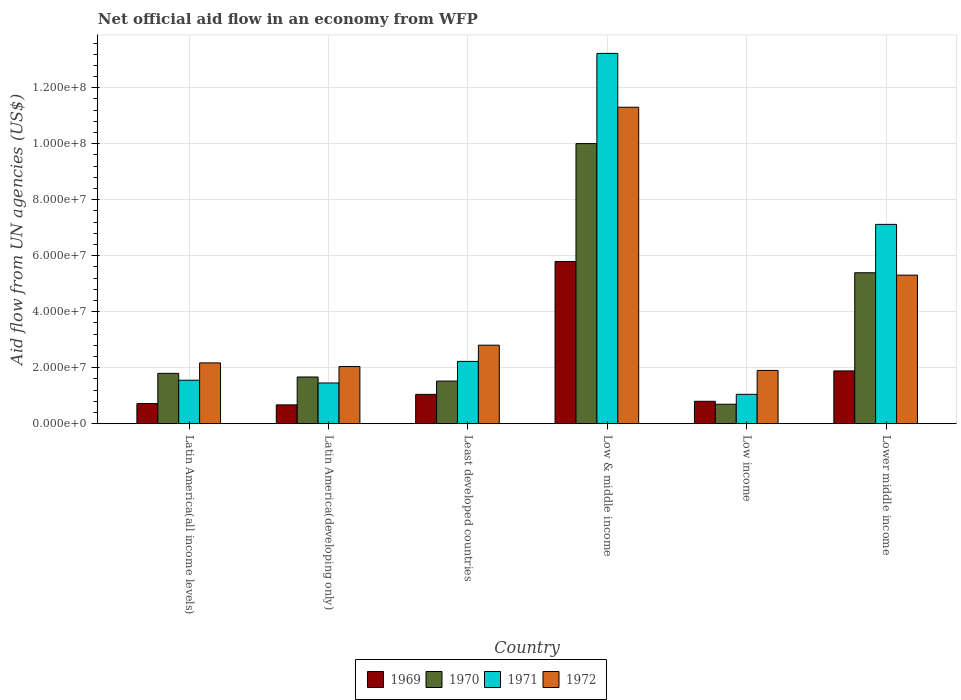How many groups of bars are there?
Offer a very short reply. 6. Are the number of bars on each tick of the X-axis equal?
Give a very brief answer. Yes. How many bars are there on the 6th tick from the left?
Ensure brevity in your answer.  4. What is the label of the 3rd group of bars from the left?
Offer a terse response. Least developed countries. What is the net official aid flow in 1972 in Lower middle income?
Provide a succinct answer. 5.31e+07. Across all countries, what is the maximum net official aid flow in 1969?
Provide a succinct answer. 5.80e+07. Across all countries, what is the minimum net official aid flow in 1970?
Give a very brief answer. 6.97e+06. In which country was the net official aid flow in 1972 minimum?
Your answer should be compact. Low income. What is the total net official aid flow in 1969 in the graph?
Offer a terse response. 1.09e+08. What is the difference between the net official aid flow in 1971 in Latin America(all income levels) and that in Lower middle income?
Provide a succinct answer. -5.57e+07. What is the difference between the net official aid flow in 1972 in Low income and the net official aid flow in 1971 in Latin America(developing only)?
Make the answer very short. 4.48e+06. What is the average net official aid flow in 1971 per country?
Provide a short and direct response. 4.44e+07. What is the difference between the net official aid flow of/in 1969 and net official aid flow of/in 1972 in Low income?
Your response must be concise. -1.10e+07. What is the ratio of the net official aid flow in 1970 in Low income to that in Lower middle income?
Offer a very short reply. 0.13. What is the difference between the highest and the second highest net official aid flow in 1969?
Offer a terse response. 3.91e+07. What is the difference between the highest and the lowest net official aid flow in 1972?
Give a very brief answer. 9.40e+07. In how many countries, is the net official aid flow in 1972 greater than the average net official aid flow in 1972 taken over all countries?
Provide a succinct answer. 2. What does the 3rd bar from the right in Latin America(developing only) represents?
Your answer should be compact. 1970. How many bars are there?
Your response must be concise. 24. Are all the bars in the graph horizontal?
Your answer should be very brief. No. How many countries are there in the graph?
Offer a terse response. 6. Are the values on the major ticks of Y-axis written in scientific E-notation?
Your answer should be very brief. Yes. Does the graph contain any zero values?
Ensure brevity in your answer.  No. Where does the legend appear in the graph?
Ensure brevity in your answer.  Bottom center. How many legend labels are there?
Offer a very short reply. 4. What is the title of the graph?
Your answer should be very brief. Net official aid flow in an economy from WFP. What is the label or title of the Y-axis?
Your response must be concise. Aid flow from UN agencies (US$). What is the Aid flow from UN agencies (US$) in 1969 in Latin America(all income levels)?
Give a very brief answer. 7.21e+06. What is the Aid flow from UN agencies (US$) of 1970 in Latin America(all income levels)?
Offer a terse response. 1.80e+07. What is the Aid flow from UN agencies (US$) of 1971 in Latin America(all income levels)?
Provide a short and direct response. 1.56e+07. What is the Aid flow from UN agencies (US$) in 1972 in Latin America(all income levels)?
Make the answer very short. 2.17e+07. What is the Aid flow from UN agencies (US$) of 1969 in Latin America(developing only)?
Provide a short and direct response. 6.74e+06. What is the Aid flow from UN agencies (US$) of 1970 in Latin America(developing only)?
Offer a very short reply. 1.67e+07. What is the Aid flow from UN agencies (US$) in 1971 in Latin America(developing only)?
Give a very brief answer. 1.46e+07. What is the Aid flow from UN agencies (US$) of 1972 in Latin America(developing only)?
Your answer should be very brief. 2.04e+07. What is the Aid flow from UN agencies (US$) of 1969 in Least developed countries?
Keep it short and to the point. 1.05e+07. What is the Aid flow from UN agencies (US$) in 1970 in Least developed countries?
Provide a succinct answer. 1.52e+07. What is the Aid flow from UN agencies (US$) of 1971 in Least developed countries?
Provide a short and direct response. 2.23e+07. What is the Aid flow from UN agencies (US$) in 1972 in Least developed countries?
Your answer should be very brief. 2.81e+07. What is the Aid flow from UN agencies (US$) of 1969 in Low & middle income?
Provide a short and direct response. 5.80e+07. What is the Aid flow from UN agencies (US$) in 1970 in Low & middle income?
Give a very brief answer. 1.00e+08. What is the Aid flow from UN agencies (US$) in 1971 in Low & middle income?
Your answer should be compact. 1.32e+08. What is the Aid flow from UN agencies (US$) of 1972 in Low & middle income?
Your response must be concise. 1.13e+08. What is the Aid flow from UN agencies (US$) in 1969 in Low income?
Offer a very short reply. 8.02e+06. What is the Aid flow from UN agencies (US$) in 1970 in Low income?
Your response must be concise. 6.97e+06. What is the Aid flow from UN agencies (US$) of 1971 in Low income?
Provide a short and direct response. 1.05e+07. What is the Aid flow from UN agencies (US$) of 1972 in Low income?
Your answer should be compact. 1.90e+07. What is the Aid flow from UN agencies (US$) in 1969 in Lower middle income?
Provide a short and direct response. 1.89e+07. What is the Aid flow from UN agencies (US$) of 1970 in Lower middle income?
Give a very brief answer. 5.39e+07. What is the Aid flow from UN agencies (US$) of 1971 in Lower middle income?
Make the answer very short. 7.12e+07. What is the Aid flow from UN agencies (US$) in 1972 in Lower middle income?
Offer a very short reply. 5.31e+07. Across all countries, what is the maximum Aid flow from UN agencies (US$) of 1969?
Offer a terse response. 5.80e+07. Across all countries, what is the maximum Aid flow from UN agencies (US$) of 1970?
Provide a short and direct response. 1.00e+08. Across all countries, what is the maximum Aid flow from UN agencies (US$) in 1971?
Your answer should be compact. 1.32e+08. Across all countries, what is the maximum Aid flow from UN agencies (US$) in 1972?
Your response must be concise. 1.13e+08. Across all countries, what is the minimum Aid flow from UN agencies (US$) of 1969?
Your answer should be very brief. 6.74e+06. Across all countries, what is the minimum Aid flow from UN agencies (US$) in 1970?
Offer a very short reply. 6.97e+06. Across all countries, what is the minimum Aid flow from UN agencies (US$) in 1971?
Offer a very short reply. 1.05e+07. Across all countries, what is the minimum Aid flow from UN agencies (US$) of 1972?
Ensure brevity in your answer.  1.90e+07. What is the total Aid flow from UN agencies (US$) in 1969 in the graph?
Make the answer very short. 1.09e+08. What is the total Aid flow from UN agencies (US$) of 1970 in the graph?
Ensure brevity in your answer.  2.11e+08. What is the total Aid flow from UN agencies (US$) in 1971 in the graph?
Your answer should be compact. 2.66e+08. What is the total Aid flow from UN agencies (US$) of 1972 in the graph?
Your answer should be very brief. 2.55e+08. What is the difference between the Aid flow from UN agencies (US$) in 1970 in Latin America(all income levels) and that in Latin America(developing only)?
Your response must be concise. 1.30e+06. What is the difference between the Aid flow from UN agencies (US$) in 1971 in Latin America(all income levels) and that in Latin America(developing only)?
Give a very brief answer. 9.90e+05. What is the difference between the Aid flow from UN agencies (US$) of 1972 in Latin America(all income levels) and that in Latin America(developing only)?
Provide a short and direct response. 1.30e+06. What is the difference between the Aid flow from UN agencies (US$) in 1969 in Latin America(all income levels) and that in Least developed countries?
Offer a terse response. -3.28e+06. What is the difference between the Aid flow from UN agencies (US$) in 1970 in Latin America(all income levels) and that in Least developed countries?
Offer a very short reply. 2.76e+06. What is the difference between the Aid flow from UN agencies (US$) in 1971 in Latin America(all income levels) and that in Least developed countries?
Your answer should be compact. -6.72e+06. What is the difference between the Aid flow from UN agencies (US$) in 1972 in Latin America(all income levels) and that in Least developed countries?
Ensure brevity in your answer.  -6.33e+06. What is the difference between the Aid flow from UN agencies (US$) of 1969 in Latin America(all income levels) and that in Low & middle income?
Your response must be concise. -5.08e+07. What is the difference between the Aid flow from UN agencies (US$) in 1970 in Latin America(all income levels) and that in Low & middle income?
Offer a terse response. -8.21e+07. What is the difference between the Aid flow from UN agencies (US$) in 1971 in Latin America(all income levels) and that in Low & middle income?
Your response must be concise. -1.17e+08. What is the difference between the Aid flow from UN agencies (US$) of 1972 in Latin America(all income levels) and that in Low & middle income?
Offer a very short reply. -9.13e+07. What is the difference between the Aid flow from UN agencies (US$) in 1969 in Latin America(all income levels) and that in Low income?
Give a very brief answer. -8.10e+05. What is the difference between the Aid flow from UN agencies (US$) of 1970 in Latin America(all income levels) and that in Low income?
Your response must be concise. 1.10e+07. What is the difference between the Aid flow from UN agencies (US$) of 1971 in Latin America(all income levels) and that in Low income?
Your response must be concise. 5.04e+06. What is the difference between the Aid flow from UN agencies (US$) in 1972 in Latin America(all income levels) and that in Low income?
Provide a short and direct response. 2.69e+06. What is the difference between the Aid flow from UN agencies (US$) of 1969 in Latin America(all income levels) and that in Lower middle income?
Keep it short and to the point. -1.17e+07. What is the difference between the Aid flow from UN agencies (US$) of 1970 in Latin America(all income levels) and that in Lower middle income?
Give a very brief answer. -3.59e+07. What is the difference between the Aid flow from UN agencies (US$) of 1971 in Latin America(all income levels) and that in Lower middle income?
Your answer should be very brief. -5.57e+07. What is the difference between the Aid flow from UN agencies (US$) in 1972 in Latin America(all income levels) and that in Lower middle income?
Give a very brief answer. -3.14e+07. What is the difference between the Aid flow from UN agencies (US$) in 1969 in Latin America(developing only) and that in Least developed countries?
Your answer should be very brief. -3.75e+06. What is the difference between the Aid flow from UN agencies (US$) in 1970 in Latin America(developing only) and that in Least developed countries?
Your answer should be very brief. 1.46e+06. What is the difference between the Aid flow from UN agencies (US$) in 1971 in Latin America(developing only) and that in Least developed countries?
Provide a short and direct response. -7.71e+06. What is the difference between the Aid flow from UN agencies (US$) in 1972 in Latin America(developing only) and that in Least developed countries?
Your response must be concise. -7.63e+06. What is the difference between the Aid flow from UN agencies (US$) of 1969 in Latin America(developing only) and that in Low & middle income?
Offer a terse response. -5.12e+07. What is the difference between the Aid flow from UN agencies (US$) in 1970 in Latin America(developing only) and that in Low & middle income?
Give a very brief answer. -8.34e+07. What is the difference between the Aid flow from UN agencies (US$) in 1971 in Latin America(developing only) and that in Low & middle income?
Ensure brevity in your answer.  -1.18e+08. What is the difference between the Aid flow from UN agencies (US$) in 1972 in Latin America(developing only) and that in Low & middle income?
Ensure brevity in your answer.  -9.26e+07. What is the difference between the Aid flow from UN agencies (US$) in 1969 in Latin America(developing only) and that in Low income?
Ensure brevity in your answer.  -1.28e+06. What is the difference between the Aid flow from UN agencies (US$) of 1970 in Latin America(developing only) and that in Low income?
Offer a terse response. 9.73e+06. What is the difference between the Aid flow from UN agencies (US$) of 1971 in Latin America(developing only) and that in Low income?
Keep it short and to the point. 4.05e+06. What is the difference between the Aid flow from UN agencies (US$) of 1972 in Latin America(developing only) and that in Low income?
Your response must be concise. 1.39e+06. What is the difference between the Aid flow from UN agencies (US$) of 1969 in Latin America(developing only) and that in Lower middle income?
Make the answer very short. -1.21e+07. What is the difference between the Aid flow from UN agencies (US$) in 1970 in Latin America(developing only) and that in Lower middle income?
Keep it short and to the point. -3.72e+07. What is the difference between the Aid flow from UN agencies (US$) in 1971 in Latin America(developing only) and that in Lower middle income?
Make the answer very short. -5.66e+07. What is the difference between the Aid flow from UN agencies (US$) in 1972 in Latin America(developing only) and that in Lower middle income?
Offer a very short reply. -3.26e+07. What is the difference between the Aid flow from UN agencies (US$) of 1969 in Least developed countries and that in Low & middle income?
Give a very brief answer. -4.75e+07. What is the difference between the Aid flow from UN agencies (US$) of 1970 in Least developed countries and that in Low & middle income?
Make the answer very short. -8.48e+07. What is the difference between the Aid flow from UN agencies (US$) of 1971 in Least developed countries and that in Low & middle income?
Your answer should be compact. -1.10e+08. What is the difference between the Aid flow from UN agencies (US$) in 1972 in Least developed countries and that in Low & middle income?
Your answer should be compact. -8.50e+07. What is the difference between the Aid flow from UN agencies (US$) of 1969 in Least developed countries and that in Low income?
Offer a terse response. 2.47e+06. What is the difference between the Aid flow from UN agencies (US$) in 1970 in Least developed countries and that in Low income?
Give a very brief answer. 8.27e+06. What is the difference between the Aid flow from UN agencies (US$) of 1971 in Least developed countries and that in Low income?
Make the answer very short. 1.18e+07. What is the difference between the Aid flow from UN agencies (US$) of 1972 in Least developed countries and that in Low income?
Your answer should be compact. 9.02e+06. What is the difference between the Aid flow from UN agencies (US$) of 1969 in Least developed countries and that in Lower middle income?
Offer a very short reply. -8.38e+06. What is the difference between the Aid flow from UN agencies (US$) of 1970 in Least developed countries and that in Lower middle income?
Provide a succinct answer. -3.87e+07. What is the difference between the Aid flow from UN agencies (US$) of 1971 in Least developed countries and that in Lower middle income?
Make the answer very short. -4.89e+07. What is the difference between the Aid flow from UN agencies (US$) of 1972 in Least developed countries and that in Lower middle income?
Keep it short and to the point. -2.50e+07. What is the difference between the Aid flow from UN agencies (US$) of 1969 in Low & middle income and that in Low income?
Ensure brevity in your answer.  4.99e+07. What is the difference between the Aid flow from UN agencies (US$) in 1970 in Low & middle income and that in Low income?
Provide a succinct answer. 9.31e+07. What is the difference between the Aid flow from UN agencies (US$) of 1971 in Low & middle income and that in Low income?
Your answer should be compact. 1.22e+08. What is the difference between the Aid flow from UN agencies (US$) in 1972 in Low & middle income and that in Low income?
Your answer should be compact. 9.40e+07. What is the difference between the Aid flow from UN agencies (US$) in 1969 in Low & middle income and that in Lower middle income?
Provide a succinct answer. 3.91e+07. What is the difference between the Aid flow from UN agencies (US$) in 1970 in Low & middle income and that in Lower middle income?
Your response must be concise. 4.61e+07. What is the difference between the Aid flow from UN agencies (US$) of 1971 in Low & middle income and that in Lower middle income?
Your answer should be very brief. 6.11e+07. What is the difference between the Aid flow from UN agencies (US$) of 1972 in Low & middle income and that in Lower middle income?
Keep it short and to the point. 6.00e+07. What is the difference between the Aid flow from UN agencies (US$) in 1969 in Low income and that in Lower middle income?
Offer a terse response. -1.08e+07. What is the difference between the Aid flow from UN agencies (US$) of 1970 in Low income and that in Lower middle income?
Make the answer very short. -4.70e+07. What is the difference between the Aid flow from UN agencies (US$) in 1971 in Low income and that in Lower middle income?
Give a very brief answer. -6.07e+07. What is the difference between the Aid flow from UN agencies (US$) in 1972 in Low income and that in Lower middle income?
Your answer should be very brief. -3.40e+07. What is the difference between the Aid flow from UN agencies (US$) in 1969 in Latin America(all income levels) and the Aid flow from UN agencies (US$) in 1970 in Latin America(developing only)?
Make the answer very short. -9.49e+06. What is the difference between the Aid flow from UN agencies (US$) in 1969 in Latin America(all income levels) and the Aid flow from UN agencies (US$) in 1971 in Latin America(developing only)?
Your answer should be very brief. -7.35e+06. What is the difference between the Aid flow from UN agencies (US$) in 1969 in Latin America(all income levels) and the Aid flow from UN agencies (US$) in 1972 in Latin America(developing only)?
Offer a terse response. -1.32e+07. What is the difference between the Aid flow from UN agencies (US$) of 1970 in Latin America(all income levels) and the Aid flow from UN agencies (US$) of 1971 in Latin America(developing only)?
Keep it short and to the point. 3.44e+06. What is the difference between the Aid flow from UN agencies (US$) of 1970 in Latin America(all income levels) and the Aid flow from UN agencies (US$) of 1972 in Latin America(developing only)?
Keep it short and to the point. -2.43e+06. What is the difference between the Aid flow from UN agencies (US$) in 1971 in Latin America(all income levels) and the Aid flow from UN agencies (US$) in 1972 in Latin America(developing only)?
Make the answer very short. -4.88e+06. What is the difference between the Aid flow from UN agencies (US$) in 1969 in Latin America(all income levels) and the Aid flow from UN agencies (US$) in 1970 in Least developed countries?
Keep it short and to the point. -8.03e+06. What is the difference between the Aid flow from UN agencies (US$) in 1969 in Latin America(all income levels) and the Aid flow from UN agencies (US$) in 1971 in Least developed countries?
Ensure brevity in your answer.  -1.51e+07. What is the difference between the Aid flow from UN agencies (US$) of 1969 in Latin America(all income levels) and the Aid flow from UN agencies (US$) of 1972 in Least developed countries?
Ensure brevity in your answer.  -2.08e+07. What is the difference between the Aid flow from UN agencies (US$) in 1970 in Latin America(all income levels) and the Aid flow from UN agencies (US$) in 1971 in Least developed countries?
Ensure brevity in your answer.  -4.27e+06. What is the difference between the Aid flow from UN agencies (US$) of 1970 in Latin America(all income levels) and the Aid flow from UN agencies (US$) of 1972 in Least developed countries?
Your response must be concise. -1.01e+07. What is the difference between the Aid flow from UN agencies (US$) of 1971 in Latin America(all income levels) and the Aid flow from UN agencies (US$) of 1972 in Least developed countries?
Provide a short and direct response. -1.25e+07. What is the difference between the Aid flow from UN agencies (US$) in 1969 in Latin America(all income levels) and the Aid flow from UN agencies (US$) in 1970 in Low & middle income?
Offer a terse response. -9.29e+07. What is the difference between the Aid flow from UN agencies (US$) of 1969 in Latin America(all income levels) and the Aid flow from UN agencies (US$) of 1971 in Low & middle income?
Your answer should be compact. -1.25e+08. What is the difference between the Aid flow from UN agencies (US$) in 1969 in Latin America(all income levels) and the Aid flow from UN agencies (US$) in 1972 in Low & middle income?
Keep it short and to the point. -1.06e+08. What is the difference between the Aid flow from UN agencies (US$) in 1970 in Latin America(all income levels) and the Aid flow from UN agencies (US$) in 1971 in Low & middle income?
Your response must be concise. -1.14e+08. What is the difference between the Aid flow from UN agencies (US$) of 1970 in Latin America(all income levels) and the Aid flow from UN agencies (US$) of 1972 in Low & middle income?
Offer a very short reply. -9.51e+07. What is the difference between the Aid flow from UN agencies (US$) of 1971 in Latin America(all income levels) and the Aid flow from UN agencies (US$) of 1972 in Low & middle income?
Your answer should be very brief. -9.75e+07. What is the difference between the Aid flow from UN agencies (US$) in 1969 in Latin America(all income levels) and the Aid flow from UN agencies (US$) in 1971 in Low income?
Ensure brevity in your answer.  -3.30e+06. What is the difference between the Aid flow from UN agencies (US$) in 1969 in Latin America(all income levels) and the Aid flow from UN agencies (US$) in 1972 in Low income?
Make the answer very short. -1.18e+07. What is the difference between the Aid flow from UN agencies (US$) of 1970 in Latin America(all income levels) and the Aid flow from UN agencies (US$) of 1971 in Low income?
Your answer should be very brief. 7.49e+06. What is the difference between the Aid flow from UN agencies (US$) of 1970 in Latin America(all income levels) and the Aid flow from UN agencies (US$) of 1972 in Low income?
Provide a short and direct response. -1.04e+06. What is the difference between the Aid flow from UN agencies (US$) of 1971 in Latin America(all income levels) and the Aid flow from UN agencies (US$) of 1972 in Low income?
Ensure brevity in your answer.  -3.49e+06. What is the difference between the Aid flow from UN agencies (US$) in 1969 in Latin America(all income levels) and the Aid flow from UN agencies (US$) in 1970 in Lower middle income?
Make the answer very short. -4.67e+07. What is the difference between the Aid flow from UN agencies (US$) in 1969 in Latin America(all income levels) and the Aid flow from UN agencies (US$) in 1971 in Lower middle income?
Your response must be concise. -6.40e+07. What is the difference between the Aid flow from UN agencies (US$) in 1969 in Latin America(all income levels) and the Aid flow from UN agencies (US$) in 1972 in Lower middle income?
Make the answer very short. -4.59e+07. What is the difference between the Aid flow from UN agencies (US$) in 1970 in Latin America(all income levels) and the Aid flow from UN agencies (US$) in 1971 in Lower middle income?
Your answer should be compact. -5.32e+07. What is the difference between the Aid flow from UN agencies (US$) of 1970 in Latin America(all income levels) and the Aid flow from UN agencies (US$) of 1972 in Lower middle income?
Provide a short and direct response. -3.51e+07. What is the difference between the Aid flow from UN agencies (US$) in 1971 in Latin America(all income levels) and the Aid flow from UN agencies (US$) in 1972 in Lower middle income?
Your response must be concise. -3.75e+07. What is the difference between the Aid flow from UN agencies (US$) of 1969 in Latin America(developing only) and the Aid flow from UN agencies (US$) of 1970 in Least developed countries?
Give a very brief answer. -8.50e+06. What is the difference between the Aid flow from UN agencies (US$) in 1969 in Latin America(developing only) and the Aid flow from UN agencies (US$) in 1971 in Least developed countries?
Provide a succinct answer. -1.55e+07. What is the difference between the Aid flow from UN agencies (US$) in 1969 in Latin America(developing only) and the Aid flow from UN agencies (US$) in 1972 in Least developed countries?
Offer a very short reply. -2.13e+07. What is the difference between the Aid flow from UN agencies (US$) in 1970 in Latin America(developing only) and the Aid flow from UN agencies (US$) in 1971 in Least developed countries?
Your response must be concise. -5.57e+06. What is the difference between the Aid flow from UN agencies (US$) of 1970 in Latin America(developing only) and the Aid flow from UN agencies (US$) of 1972 in Least developed countries?
Keep it short and to the point. -1.14e+07. What is the difference between the Aid flow from UN agencies (US$) of 1971 in Latin America(developing only) and the Aid flow from UN agencies (US$) of 1972 in Least developed countries?
Give a very brief answer. -1.35e+07. What is the difference between the Aid flow from UN agencies (US$) of 1969 in Latin America(developing only) and the Aid flow from UN agencies (US$) of 1970 in Low & middle income?
Make the answer very short. -9.33e+07. What is the difference between the Aid flow from UN agencies (US$) in 1969 in Latin America(developing only) and the Aid flow from UN agencies (US$) in 1971 in Low & middle income?
Provide a short and direct response. -1.26e+08. What is the difference between the Aid flow from UN agencies (US$) of 1969 in Latin America(developing only) and the Aid flow from UN agencies (US$) of 1972 in Low & middle income?
Your response must be concise. -1.06e+08. What is the difference between the Aid flow from UN agencies (US$) of 1970 in Latin America(developing only) and the Aid flow from UN agencies (US$) of 1971 in Low & middle income?
Provide a succinct answer. -1.16e+08. What is the difference between the Aid flow from UN agencies (US$) of 1970 in Latin America(developing only) and the Aid flow from UN agencies (US$) of 1972 in Low & middle income?
Provide a short and direct response. -9.64e+07. What is the difference between the Aid flow from UN agencies (US$) in 1971 in Latin America(developing only) and the Aid flow from UN agencies (US$) in 1972 in Low & middle income?
Ensure brevity in your answer.  -9.85e+07. What is the difference between the Aid flow from UN agencies (US$) in 1969 in Latin America(developing only) and the Aid flow from UN agencies (US$) in 1970 in Low income?
Provide a succinct answer. -2.30e+05. What is the difference between the Aid flow from UN agencies (US$) in 1969 in Latin America(developing only) and the Aid flow from UN agencies (US$) in 1971 in Low income?
Ensure brevity in your answer.  -3.77e+06. What is the difference between the Aid flow from UN agencies (US$) in 1969 in Latin America(developing only) and the Aid flow from UN agencies (US$) in 1972 in Low income?
Keep it short and to the point. -1.23e+07. What is the difference between the Aid flow from UN agencies (US$) of 1970 in Latin America(developing only) and the Aid flow from UN agencies (US$) of 1971 in Low income?
Provide a succinct answer. 6.19e+06. What is the difference between the Aid flow from UN agencies (US$) in 1970 in Latin America(developing only) and the Aid flow from UN agencies (US$) in 1972 in Low income?
Your answer should be very brief. -2.34e+06. What is the difference between the Aid flow from UN agencies (US$) of 1971 in Latin America(developing only) and the Aid flow from UN agencies (US$) of 1972 in Low income?
Offer a very short reply. -4.48e+06. What is the difference between the Aid flow from UN agencies (US$) of 1969 in Latin America(developing only) and the Aid flow from UN agencies (US$) of 1970 in Lower middle income?
Provide a succinct answer. -4.72e+07. What is the difference between the Aid flow from UN agencies (US$) of 1969 in Latin America(developing only) and the Aid flow from UN agencies (US$) of 1971 in Lower middle income?
Provide a succinct answer. -6.45e+07. What is the difference between the Aid flow from UN agencies (US$) in 1969 in Latin America(developing only) and the Aid flow from UN agencies (US$) in 1972 in Lower middle income?
Provide a short and direct response. -4.63e+07. What is the difference between the Aid flow from UN agencies (US$) of 1970 in Latin America(developing only) and the Aid flow from UN agencies (US$) of 1971 in Lower middle income?
Make the answer very short. -5.45e+07. What is the difference between the Aid flow from UN agencies (US$) of 1970 in Latin America(developing only) and the Aid flow from UN agencies (US$) of 1972 in Lower middle income?
Keep it short and to the point. -3.64e+07. What is the difference between the Aid flow from UN agencies (US$) in 1971 in Latin America(developing only) and the Aid flow from UN agencies (US$) in 1972 in Lower middle income?
Ensure brevity in your answer.  -3.85e+07. What is the difference between the Aid flow from UN agencies (US$) in 1969 in Least developed countries and the Aid flow from UN agencies (US$) in 1970 in Low & middle income?
Provide a succinct answer. -8.96e+07. What is the difference between the Aid flow from UN agencies (US$) in 1969 in Least developed countries and the Aid flow from UN agencies (US$) in 1971 in Low & middle income?
Offer a very short reply. -1.22e+08. What is the difference between the Aid flow from UN agencies (US$) of 1969 in Least developed countries and the Aid flow from UN agencies (US$) of 1972 in Low & middle income?
Your answer should be very brief. -1.03e+08. What is the difference between the Aid flow from UN agencies (US$) in 1970 in Least developed countries and the Aid flow from UN agencies (US$) in 1971 in Low & middle income?
Ensure brevity in your answer.  -1.17e+08. What is the difference between the Aid flow from UN agencies (US$) of 1970 in Least developed countries and the Aid flow from UN agencies (US$) of 1972 in Low & middle income?
Offer a very short reply. -9.78e+07. What is the difference between the Aid flow from UN agencies (US$) in 1971 in Least developed countries and the Aid flow from UN agencies (US$) in 1972 in Low & middle income?
Your answer should be compact. -9.08e+07. What is the difference between the Aid flow from UN agencies (US$) of 1969 in Least developed countries and the Aid flow from UN agencies (US$) of 1970 in Low income?
Make the answer very short. 3.52e+06. What is the difference between the Aid flow from UN agencies (US$) in 1969 in Least developed countries and the Aid flow from UN agencies (US$) in 1972 in Low income?
Provide a succinct answer. -8.55e+06. What is the difference between the Aid flow from UN agencies (US$) in 1970 in Least developed countries and the Aid flow from UN agencies (US$) in 1971 in Low income?
Your response must be concise. 4.73e+06. What is the difference between the Aid flow from UN agencies (US$) in 1970 in Least developed countries and the Aid flow from UN agencies (US$) in 1972 in Low income?
Offer a terse response. -3.80e+06. What is the difference between the Aid flow from UN agencies (US$) of 1971 in Least developed countries and the Aid flow from UN agencies (US$) of 1972 in Low income?
Keep it short and to the point. 3.23e+06. What is the difference between the Aid flow from UN agencies (US$) in 1969 in Least developed countries and the Aid flow from UN agencies (US$) in 1970 in Lower middle income?
Your answer should be compact. -4.34e+07. What is the difference between the Aid flow from UN agencies (US$) of 1969 in Least developed countries and the Aid flow from UN agencies (US$) of 1971 in Lower middle income?
Your response must be concise. -6.07e+07. What is the difference between the Aid flow from UN agencies (US$) in 1969 in Least developed countries and the Aid flow from UN agencies (US$) in 1972 in Lower middle income?
Ensure brevity in your answer.  -4.26e+07. What is the difference between the Aid flow from UN agencies (US$) of 1970 in Least developed countries and the Aid flow from UN agencies (US$) of 1971 in Lower middle income?
Ensure brevity in your answer.  -5.60e+07. What is the difference between the Aid flow from UN agencies (US$) of 1970 in Least developed countries and the Aid flow from UN agencies (US$) of 1972 in Lower middle income?
Give a very brief answer. -3.78e+07. What is the difference between the Aid flow from UN agencies (US$) in 1971 in Least developed countries and the Aid flow from UN agencies (US$) in 1972 in Lower middle income?
Your answer should be compact. -3.08e+07. What is the difference between the Aid flow from UN agencies (US$) of 1969 in Low & middle income and the Aid flow from UN agencies (US$) of 1970 in Low income?
Provide a short and direct response. 5.10e+07. What is the difference between the Aid flow from UN agencies (US$) in 1969 in Low & middle income and the Aid flow from UN agencies (US$) in 1971 in Low income?
Keep it short and to the point. 4.74e+07. What is the difference between the Aid flow from UN agencies (US$) of 1969 in Low & middle income and the Aid flow from UN agencies (US$) of 1972 in Low income?
Your answer should be compact. 3.89e+07. What is the difference between the Aid flow from UN agencies (US$) of 1970 in Low & middle income and the Aid flow from UN agencies (US$) of 1971 in Low income?
Offer a terse response. 8.96e+07. What is the difference between the Aid flow from UN agencies (US$) in 1970 in Low & middle income and the Aid flow from UN agencies (US$) in 1972 in Low income?
Give a very brief answer. 8.10e+07. What is the difference between the Aid flow from UN agencies (US$) in 1971 in Low & middle income and the Aid flow from UN agencies (US$) in 1972 in Low income?
Your answer should be compact. 1.13e+08. What is the difference between the Aid flow from UN agencies (US$) in 1969 in Low & middle income and the Aid flow from UN agencies (US$) in 1970 in Lower middle income?
Offer a terse response. 4.03e+06. What is the difference between the Aid flow from UN agencies (US$) of 1969 in Low & middle income and the Aid flow from UN agencies (US$) of 1971 in Lower middle income?
Provide a short and direct response. -1.32e+07. What is the difference between the Aid flow from UN agencies (US$) in 1969 in Low & middle income and the Aid flow from UN agencies (US$) in 1972 in Lower middle income?
Make the answer very short. 4.88e+06. What is the difference between the Aid flow from UN agencies (US$) in 1970 in Low & middle income and the Aid flow from UN agencies (US$) in 1971 in Lower middle income?
Your answer should be compact. 2.89e+07. What is the difference between the Aid flow from UN agencies (US$) of 1970 in Low & middle income and the Aid flow from UN agencies (US$) of 1972 in Lower middle income?
Offer a terse response. 4.70e+07. What is the difference between the Aid flow from UN agencies (US$) in 1971 in Low & middle income and the Aid flow from UN agencies (US$) in 1972 in Lower middle income?
Make the answer very short. 7.92e+07. What is the difference between the Aid flow from UN agencies (US$) of 1969 in Low income and the Aid flow from UN agencies (US$) of 1970 in Lower middle income?
Provide a succinct answer. -4.59e+07. What is the difference between the Aid flow from UN agencies (US$) of 1969 in Low income and the Aid flow from UN agencies (US$) of 1971 in Lower middle income?
Provide a succinct answer. -6.32e+07. What is the difference between the Aid flow from UN agencies (US$) of 1969 in Low income and the Aid flow from UN agencies (US$) of 1972 in Lower middle income?
Your answer should be compact. -4.51e+07. What is the difference between the Aid flow from UN agencies (US$) of 1970 in Low income and the Aid flow from UN agencies (US$) of 1971 in Lower middle income?
Your answer should be compact. -6.42e+07. What is the difference between the Aid flow from UN agencies (US$) of 1970 in Low income and the Aid flow from UN agencies (US$) of 1972 in Lower middle income?
Offer a terse response. -4.61e+07. What is the difference between the Aid flow from UN agencies (US$) of 1971 in Low income and the Aid flow from UN agencies (US$) of 1972 in Lower middle income?
Keep it short and to the point. -4.26e+07. What is the average Aid flow from UN agencies (US$) of 1969 per country?
Make the answer very short. 1.82e+07. What is the average Aid flow from UN agencies (US$) in 1970 per country?
Your answer should be compact. 3.52e+07. What is the average Aid flow from UN agencies (US$) of 1971 per country?
Ensure brevity in your answer.  4.44e+07. What is the average Aid flow from UN agencies (US$) in 1972 per country?
Your answer should be compact. 4.26e+07. What is the difference between the Aid flow from UN agencies (US$) of 1969 and Aid flow from UN agencies (US$) of 1970 in Latin America(all income levels)?
Make the answer very short. -1.08e+07. What is the difference between the Aid flow from UN agencies (US$) in 1969 and Aid flow from UN agencies (US$) in 1971 in Latin America(all income levels)?
Give a very brief answer. -8.34e+06. What is the difference between the Aid flow from UN agencies (US$) in 1969 and Aid flow from UN agencies (US$) in 1972 in Latin America(all income levels)?
Give a very brief answer. -1.45e+07. What is the difference between the Aid flow from UN agencies (US$) of 1970 and Aid flow from UN agencies (US$) of 1971 in Latin America(all income levels)?
Provide a succinct answer. 2.45e+06. What is the difference between the Aid flow from UN agencies (US$) in 1970 and Aid flow from UN agencies (US$) in 1972 in Latin America(all income levels)?
Offer a very short reply. -3.73e+06. What is the difference between the Aid flow from UN agencies (US$) in 1971 and Aid flow from UN agencies (US$) in 1972 in Latin America(all income levels)?
Keep it short and to the point. -6.18e+06. What is the difference between the Aid flow from UN agencies (US$) in 1969 and Aid flow from UN agencies (US$) in 1970 in Latin America(developing only)?
Provide a short and direct response. -9.96e+06. What is the difference between the Aid flow from UN agencies (US$) of 1969 and Aid flow from UN agencies (US$) of 1971 in Latin America(developing only)?
Offer a very short reply. -7.82e+06. What is the difference between the Aid flow from UN agencies (US$) of 1969 and Aid flow from UN agencies (US$) of 1972 in Latin America(developing only)?
Your answer should be very brief. -1.37e+07. What is the difference between the Aid flow from UN agencies (US$) in 1970 and Aid flow from UN agencies (US$) in 1971 in Latin America(developing only)?
Your response must be concise. 2.14e+06. What is the difference between the Aid flow from UN agencies (US$) of 1970 and Aid flow from UN agencies (US$) of 1972 in Latin America(developing only)?
Offer a terse response. -3.73e+06. What is the difference between the Aid flow from UN agencies (US$) of 1971 and Aid flow from UN agencies (US$) of 1972 in Latin America(developing only)?
Offer a terse response. -5.87e+06. What is the difference between the Aid flow from UN agencies (US$) in 1969 and Aid flow from UN agencies (US$) in 1970 in Least developed countries?
Ensure brevity in your answer.  -4.75e+06. What is the difference between the Aid flow from UN agencies (US$) of 1969 and Aid flow from UN agencies (US$) of 1971 in Least developed countries?
Provide a short and direct response. -1.18e+07. What is the difference between the Aid flow from UN agencies (US$) in 1969 and Aid flow from UN agencies (US$) in 1972 in Least developed countries?
Give a very brief answer. -1.76e+07. What is the difference between the Aid flow from UN agencies (US$) of 1970 and Aid flow from UN agencies (US$) of 1971 in Least developed countries?
Offer a terse response. -7.03e+06. What is the difference between the Aid flow from UN agencies (US$) of 1970 and Aid flow from UN agencies (US$) of 1972 in Least developed countries?
Your response must be concise. -1.28e+07. What is the difference between the Aid flow from UN agencies (US$) in 1971 and Aid flow from UN agencies (US$) in 1972 in Least developed countries?
Your answer should be very brief. -5.79e+06. What is the difference between the Aid flow from UN agencies (US$) of 1969 and Aid flow from UN agencies (US$) of 1970 in Low & middle income?
Offer a terse response. -4.21e+07. What is the difference between the Aid flow from UN agencies (US$) in 1969 and Aid flow from UN agencies (US$) in 1971 in Low & middle income?
Give a very brief answer. -7.43e+07. What is the difference between the Aid flow from UN agencies (US$) of 1969 and Aid flow from UN agencies (US$) of 1972 in Low & middle income?
Offer a terse response. -5.51e+07. What is the difference between the Aid flow from UN agencies (US$) in 1970 and Aid flow from UN agencies (US$) in 1971 in Low & middle income?
Keep it short and to the point. -3.22e+07. What is the difference between the Aid flow from UN agencies (US$) in 1970 and Aid flow from UN agencies (US$) in 1972 in Low & middle income?
Your answer should be very brief. -1.30e+07. What is the difference between the Aid flow from UN agencies (US$) of 1971 and Aid flow from UN agencies (US$) of 1972 in Low & middle income?
Give a very brief answer. 1.92e+07. What is the difference between the Aid flow from UN agencies (US$) in 1969 and Aid flow from UN agencies (US$) in 1970 in Low income?
Your answer should be very brief. 1.05e+06. What is the difference between the Aid flow from UN agencies (US$) in 1969 and Aid flow from UN agencies (US$) in 1971 in Low income?
Provide a short and direct response. -2.49e+06. What is the difference between the Aid flow from UN agencies (US$) of 1969 and Aid flow from UN agencies (US$) of 1972 in Low income?
Give a very brief answer. -1.10e+07. What is the difference between the Aid flow from UN agencies (US$) in 1970 and Aid flow from UN agencies (US$) in 1971 in Low income?
Give a very brief answer. -3.54e+06. What is the difference between the Aid flow from UN agencies (US$) of 1970 and Aid flow from UN agencies (US$) of 1972 in Low income?
Ensure brevity in your answer.  -1.21e+07. What is the difference between the Aid flow from UN agencies (US$) of 1971 and Aid flow from UN agencies (US$) of 1972 in Low income?
Provide a short and direct response. -8.53e+06. What is the difference between the Aid flow from UN agencies (US$) in 1969 and Aid flow from UN agencies (US$) in 1970 in Lower middle income?
Ensure brevity in your answer.  -3.51e+07. What is the difference between the Aid flow from UN agencies (US$) of 1969 and Aid flow from UN agencies (US$) of 1971 in Lower middle income?
Your answer should be compact. -5.23e+07. What is the difference between the Aid flow from UN agencies (US$) of 1969 and Aid flow from UN agencies (US$) of 1972 in Lower middle income?
Offer a terse response. -3.42e+07. What is the difference between the Aid flow from UN agencies (US$) of 1970 and Aid flow from UN agencies (US$) of 1971 in Lower middle income?
Provide a succinct answer. -1.73e+07. What is the difference between the Aid flow from UN agencies (US$) in 1970 and Aid flow from UN agencies (US$) in 1972 in Lower middle income?
Keep it short and to the point. 8.50e+05. What is the difference between the Aid flow from UN agencies (US$) of 1971 and Aid flow from UN agencies (US$) of 1972 in Lower middle income?
Provide a short and direct response. 1.81e+07. What is the ratio of the Aid flow from UN agencies (US$) in 1969 in Latin America(all income levels) to that in Latin America(developing only)?
Your answer should be compact. 1.07. What is the ratio of the Aid flow from UN agencies (US$) in 1970 in Latin America(all income levels) to that in Latin America(developing only)?
Make the answer very short. 1.08. What is the ratio of the Aid flow from UN agencies (US$) in 1971 in Latin America(all income levels) to that in Latin America(developing only)?
Your response must be concise. 1.07. What is the ratio of the Aid flow from UN agencies (US$) of 1972 in Latin America(all income levels) to that in Latin America(developing only)?
Make the answer very short. 1.06. What is the ratio of the Aid flow from UN agencies (US$) in 1969 in Latin America(all income levels) to that in Least developed countries?
Ensure brevity in your answer.  0.69. What is the ratio of the Aid flow from UN agencies (US$) in 1970 in Latin America(all income levels) to that in Least developed countries?
Your answer should be very brief. 1.18. What is the ratio of the Aid flow from UN agencies (US$) in 1971 in Latin America(all income levels) to that in Least developed countries?
Your answer should be compact. 0.7. What is the ratio of the Aid flow from UN agencies (US$) in 1972 in Latin America(all income levels) to that in Least developed countries?
Keep it short and to the point. 0.77. What is the ratio of the Aid flow from UN agencies (US$) of 1969 in Latin America(all income levels) to that in Low & middle income?
Ensure brevity in your answer.  0.12. What is the ratio of the Aid flow from UN agencies (US$) of 1970 in Latin America(all income levels) to that in Low & middle income?
Your response must be concise. 0.18. What is the ratio of the Aid flow from UN agencies (US$) in 1971 in Latin America(all income levels) to that in Low & middle income?
Offer a terse response. 0.12. What is the ratio of the Aid flow from UN agencies (US$) in 1972 in Latin America(all income levels) to that in Low & middle income?
Ensure brevity in your answer.  0.19. What is the ratio of the Aid flow from UN agencies (US$) in 1969 in Latin America(all income levels) to that in Low income?
Provide a succinct answer. 0.9. What is the ratio of the Aid flow from UN agencies (US$) in 1970 in Latin America(all income levels) to that in Low income?
Your answer should be compact. 2.58. What is the ratio of the Aid flow from UN agencies (US$) in 1971 in Latin America(all income levels) to that in Low income?
Your answer should be compact. 1.48. What is the ratio of the Aid flow from UN agencies (US$) of 1972 in Latin America(all income levels) to that in Low income?
Your response must be concise. 1.14. What is the ratio of the Aid flow from UN agencies (US$) of 1969 in Latin America(all income levels) to that in Lower middle income?
Make the answer very short. 0.38. What is the ratio of the Aid flow from UN agencies (US$) of 1970 in Latin America(all income levels) to that in Lower middle income?
Your answer should be compact. 0.33. What is the ratio of the Aid flow from UN agencies (US$) in 1971 in Latin America(all income levels) to that in Lower middle income?
Provide a short and direct response. 0.22. What is the ratio of the Aid flow from UN agencies (US$) of 1972 in Latin America(all income levels) to that in Lower middle income?
Provide a succinct answer. 0.41. What is the ratio of the Aid flow from UN agencies (US$) of 1969 in Latin America(developing only) to that in Least developed countries?
Keep it short and to the point. 0.64. What is the ratio of the Aid flow from UN agencies (US$) of 1970 in Latin America(developing only) to that in Least developed countries?
Your response must be concise. 1.1. What is the ratio of the Aid flow from UN agencies (US$) of 1971 in Latin America(developing only) to that in Least developed countries?
Your response must be concise. 0.65. What is the ratio of the Aid flow from UN agencies (US$) of 1972 in Latin America(developing only) to that in Least developed countries?
Provide a succinct answer. 0.73. What is the ratio of the Aid flow from UN agencies (US$) of 1969 in Latin America(developing only) to that in Low & middle income?
Your answer should be very brief. 0.12. What is the ratio of the Aid flow from UN agencies (US$) in 1970 in Latin America(developing only) to that in Low & middle income?
Your response must be concise. 0.17. What is the ratio of the Aid flow from UN agencies (US$) of 1971 in Latin America(developing only) to that in Low & middle income?
Ensure brevity in your answer.  0.11. What is the ratio of the Aid flow from UN agencies (US$) in 1972 in Latin America(developing only) to that in Low & middle income?
Ensure brevity in your answer.  0.18. What is the ratio of the Aid flow from UN agencies (US$) of 1969 in Latin America(developing only) to that in Low income?
Provide a short and direct response. 0.84. What is the ratio of the Aid flow from UN agencies (US$) of 1970 in Latin America(developing only) to that in Low income?
Your response must be concise. 2.4. What is the ratio of the Aid flow from UN agencies (US$) in 1971 in Latin America(developing only) to that in Low income?
Ensure brevity in your answer.  1.39. What is the ratio of the Aid flow from UN agencies (US$) in 1972 in Latin America(developing only) to that in Low income?
Your answer should be compact. 1.07. What is the ratio of the Aid flow from UN agencies (US$) of 1969 in Latin America(developing only) to that in Lower middle income?
Offer a very short reply. 0.36. What is the ratio of the Aid flow from UN agencies (US$) in 1970 in Latin America(developing only) to that in Lower middle income?
Offer a terse response. 0.31. What is the ratio of the Aid flow from UN agencies (US$) of 1971 in Latin America(developing only) to that in Lower middle income?
Offer a terse response. 0.2. What is the ratio of the Aid flow from UN agencies (US$) of 1972 in Latin America(developing only) to that in Lower middle income?
Your answer should be compact. 0.38. What is the ratio of the Aid flow from UN agencies (US$) in 1969 in Least developed countries to that in Low & middle income?
Ensure brevity in your answer.  0.18. What is the ratio of the Aid flow from UN agencies (US$) of 1970 in Least developed countries to that in Low & middle income?
Your answer should be very brief. 0.15. What is the ratio of the Aid flow from UN agencies (US$) of 1971 in Least developed countries to that in Low & middle income?
Make the answer very short. 0.17. What is the ratio of the Aid flow from UN agencies (US$) of 1972 in Least developed countries to that in Low & middle income?
Your answer should be very brief. 0.25. What is the ratio of the Aid flow from UN agencies (US$) of 1969 in Least developed countries to that in Low income?
Provide a short and direct response. 1.31. What is the ratio of the Aid flow from UN agencies (US$) of 1970 in Least developed countries to that in Low income?
Keep it short and to the point. 2.19. What is the ratio of the Aid flow from UN agencies (US$) in 1971 in Least developed countries to that in Low income?
Provide a short and direct response. 2.12. What is the ratio of the Aid flow from UN agencies (US$) in 1972 in Least developed countries to that in Low income?
Offer a terse response. 1.47. What is the ratio of the Aid flow from UN agencies (US$) in 1969 in Least developed countries to that in Lower middle income?
Provide a succinct answer. 0.56. What is the ratio of the Aid flow from UN agencies (US$) in 1970 in Least developed countries to that in Lower middle income?
Make the answer very short. 0.28. What is the ratio of the Aid flow from UN agencies (US$) in 1971 in Least developed countries to that in Lower middle income?
Keep it short and to the point. 0.31. What is the ratio of the Aid flow from UN agencies (US$) in 1972 in Least developed countries to that in Lower middle income?
Provide a short and direct response. 0.53. What is the ratio of the Aid flow from UN agencies (US$) in 1969 in Low & middle income to that in Low income?
Your response must be concise. 7.23. What is the ratio of the Aid flow from UN agencies (US$) in 1970 in Low & middle income to that in Low income?
Ensure brevity in your answer.  14.36. What is the ratio of the Aid flow from UN agencies (US$) of 1971 in Low & middle income to that in Low income?
Make the answer very short. 12.59. What is the ratio of the Aid flow from UN agencies (US$) in 1972 in Low & middle income to that in Low income?
Ensure brevity in your answer.  5.94. What is the ratio of the Aid flow from UN agencies (US$) of 1969 in Low & middle income to that in Lower middle income?
Keep it short and to the point. 3.07. What is the ratio of the Aid flow from UN agencies (US$) in 1970 in Low & middle income to that in Lower middle income?
Ensure brevity in your answer.  1.86. What is the ratio of the Aid flow from UN agencies (US$) in 1971 in Low & middle income to that in Lower middle income?
Offer a very short reply. 1.86. What is the ratio of the Aid flow from UN agencies (US$) in 1972 in Low & middle income to that in Lower middle income?
Your answer should be compact. 2.13. What is the ratio of the Aid flow from UN agencies (US$) of 1969 in Low income to that in Lower middle income?
Provide a succinct answer. 0.42. What is the ratio of the Aid flow from UN agencies (US$) in 1970 in Low income to that in Lower middle income?
Provide a succinct answer. 0.13. What is the ratio of the Aid flow from UN agencies (US$) of 1971 in Low income to that in Lower middle income?
Give a very brief answer. 0.15. What is the ratio of the Aid flow from UN agencies (US$) in 1972 in Low income to that in Lower middle income?
Your response must be concise. 0.36. What is the difference between the highest and the second highest Aid flow from UN agencies (US$) of 1969?
Your response must be concise. 3.91e+07. What is the difference between the highest and the second highest Aid flow from UN agencies (US$) in 1970?
Offer a very short reply. 4.61e+07. What is the difference between the highest and the second highest Aid flow from UN agencies (US$) of 1971?
Offer a terse response. 6.11e+07. What is the difference between the highest and the second highest Aid flow from UN agencies (US$) of 1972?
Offer a very short reply. 6.00e+07. What is the difference between the highest and the lowest Aid flow from UN agencies (US$) of 1969?
Offer a very short reply. 5.12e+07. What is the difference between the highest and the lowest Aid flow from UN agencies (US$) in 1970?
Offer a very short reply. 9.31e+07. What is the difference between the highest and the lowest Aid flow from UN agencies (US$) of 1971?
Your answer should be very brief. 1.22e+08. What is the difference between the highest and the lowest Aid flow from UN agencies (US$) in 1972?
Provide a succinct answer. 9.40e+07. 